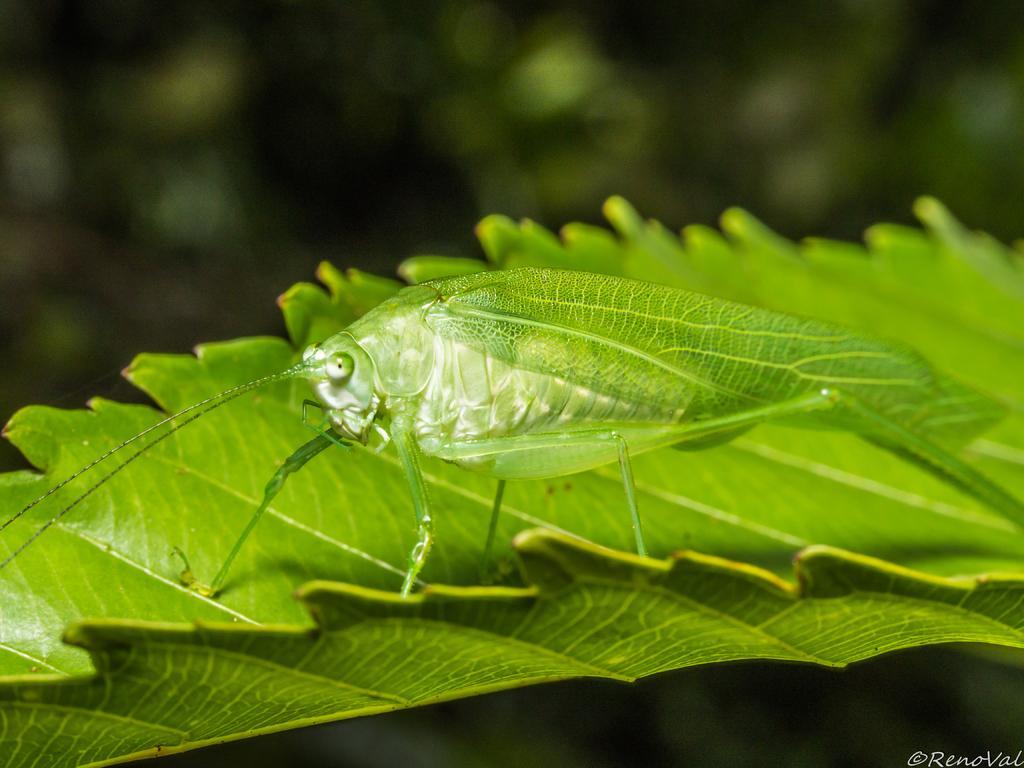Please provide a concise description of this image. In the picture I can see a green color insect on green color leaf. The background of the image is blurred and dark. Here we can see a watermark at the bottom right side of the image. 